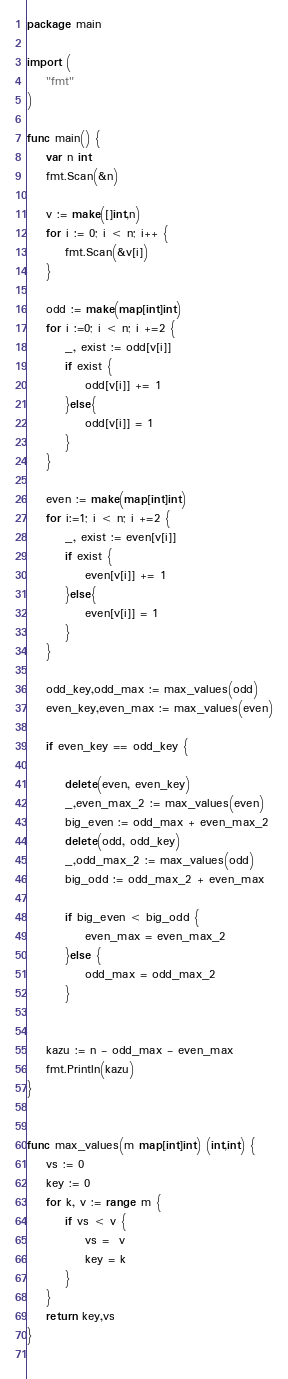Convert code to text. <code><loc_0><loc_0><loc_500><loc_500><_Go_>package main

import (
	"fmt"
)

func main() {
	var n int
	fmt.Scan(&n)

	v := make([]int,n)
	for i := 0; i < n; i++ {
		fmt.Scan(&v[i])
	}

	odd := make(map[int]int)
	for i :=0; i < n; i +=2 {
		_, exist := odd[v[i]]
		if exist {
			odd[v[i]] += 1
		}else{
			odd[v[i]] = 1
		}
	}

	even := make(map[int]int)
	for i:=1; i < n; i +=2 {
		_, exist := even[v[i]]
		if exist {
			even[v[i]] += 1
		}else{
			even[v[i]] = 1
		}
	}

	odd_key,odd_max := max_values(odd)
	even_key,even_max := max_values(even)
	
	if even_key == odd_key {
		
		delete(even, even_key)
		_,even_max_2 := max_values(even)
		big_even := odd_max + even_max_2
		delete(odd, odd_key)
		_,odd_max_2 := max_values(odd)
		big_odd := odd_max_2 + even_max

		if big_even < big_odd {
			even_max = even_max_2
		}else {
			odd_max = odd_max_2
		}

	
	kazu := n - odd_max - even_max
	fmt.Println(kazu)
}


func max_values(m map[int]int) (int,int) {
	vs := 0
	key := 0 
	for k, v := range m {
		if vs < v {
			vs =  v
			key = k
		}
	}
	return key,vs
}
		


</code> 